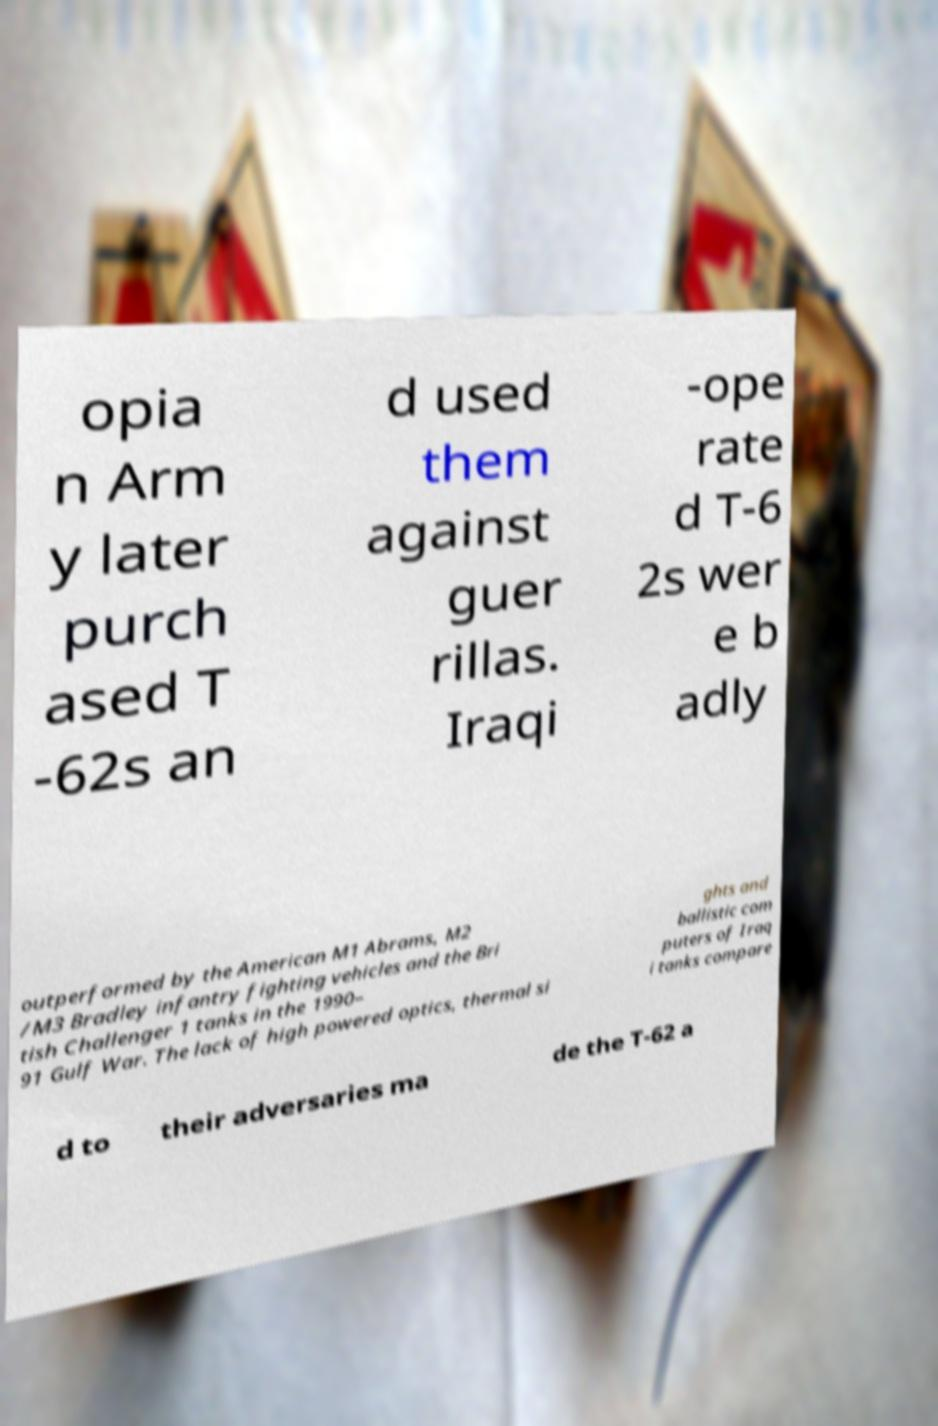Can you accurately transcribe the text from the provided image for me? opia n Arm y later purch ased T -62s an d used them against guer rillas. Iraqi -ope rate d T-6 2s wer e b adly outperformed by the American M1 Abrams, M2 /M3 Bradley infantry fighting vehicles and the Bri tish Challenger 1 tanks in the 1990– 91 Gulf War. The lack of high powered optics, thermal si ghts and ballistic com puters of Iraq i tanks compare d to their adversaries ma de the T-62 a 